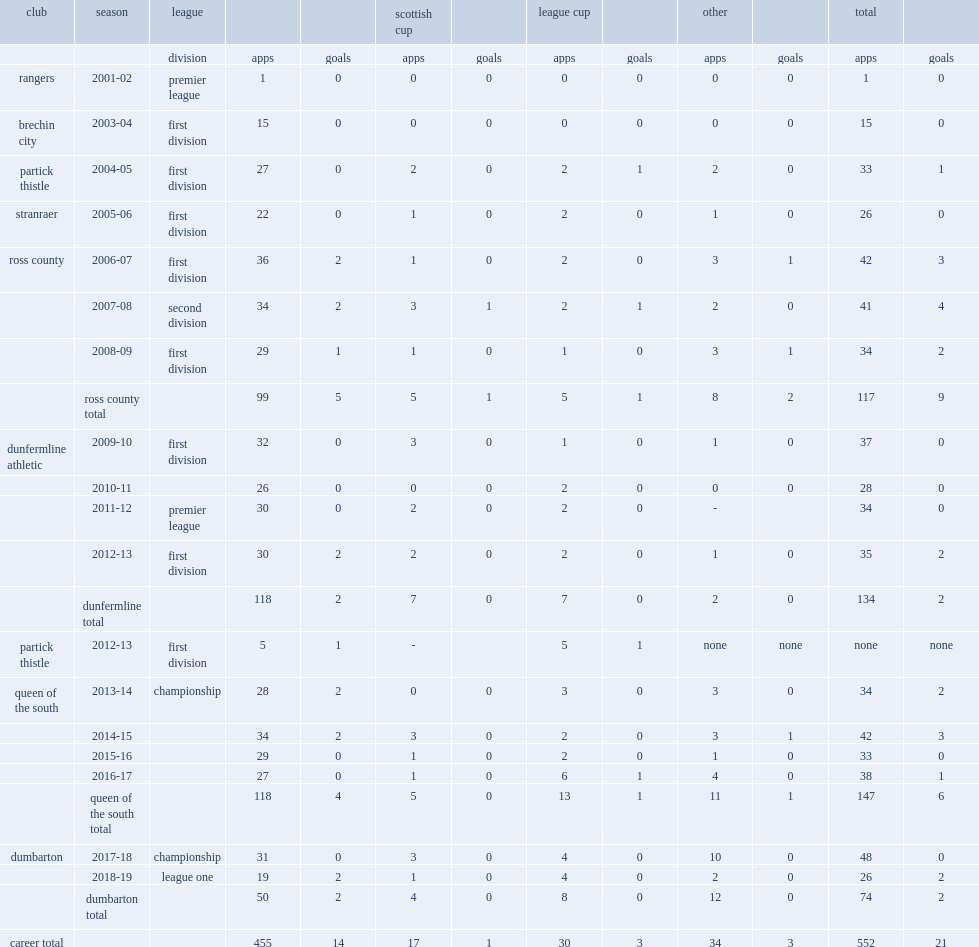What was the total muber of appearances made by queen of the south? 147.0. 